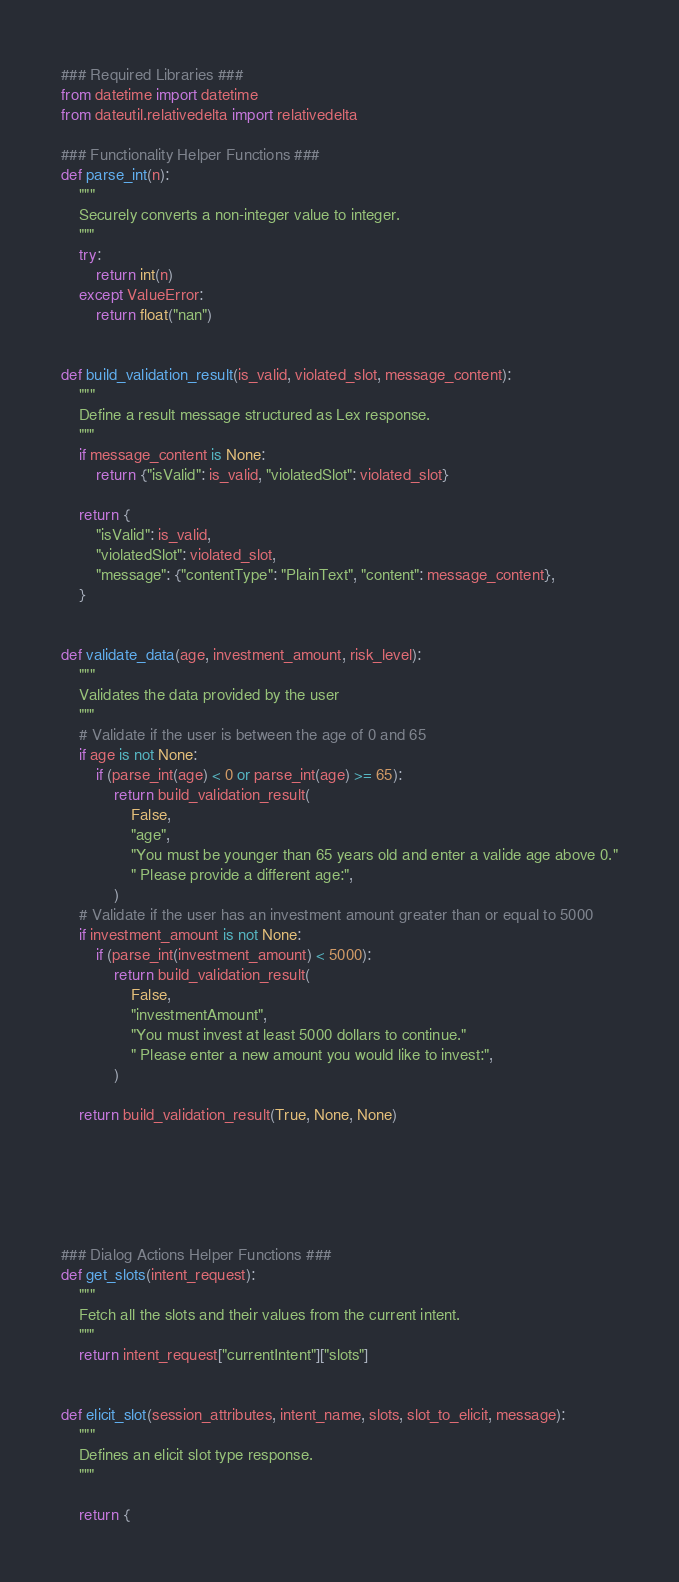<code> <loc_0><loc_0><loc_500><loc_500><_Python_>### Required Libraries ###
from datetime import datetime
from dateutil.relativedelta import relativedelta

### Functionality Helper Functions ###
def parse_int(n):
    """
    Securely converts a non-integer value to integer.
    """
    try:
        return int(n)
    except ValueError:
        return float("nan")


def build_validation_result(is_valid, violated_slot, message_content):
    """
    Define a result message structured as Lex response.
    """
    if message_content is None:
        return {"isValid": is_valid, "violatedSlot": violated_slot}

    return {
        "isValid": is_valid,
        "violatedSlot": violated_slot,
        "message": {"contentType": "PlainText", "content": message_content},
    }


def validate_data(age, investment_amount, risk_level):
    """
    Validates the data provided by the user
    """
    # Validate if the user is between the age of 0 and 65
    if age is not None:
        if (parse_int(age) < 0 or parse_int(age) >= 65):
            return build_validation_result(
                False,
                "age",
                "You must be younger than 65 years old and enter a valide age above 0."
                " Please provide a different age:",
            )
    # Validate if the user has an investment amount greater than or equal to 5000
    if investment_amount is not None:
        if (parse_int(investment_amount) < 5000):
            return build_validation_result(
                False,
                "investmentAmount",
                "You must invest at least 5000 dollars to continue."
                " Please enter a new amount you would like to invest:",
            )

    return build_validation_result(True, None, None)

    




### Dialog Actions Helper Functions ###
def get_slots(intent_request):
    """
    Fetch all the slots and their values from the current intent.
    """
    return intent_request["currentIntent"]["slots"]


def elicit_slot(session_attributes, intent_name, slots, slot_to_elicit, message):
    """
    Defines an elicit slot type response.
    """

    return {</code> 